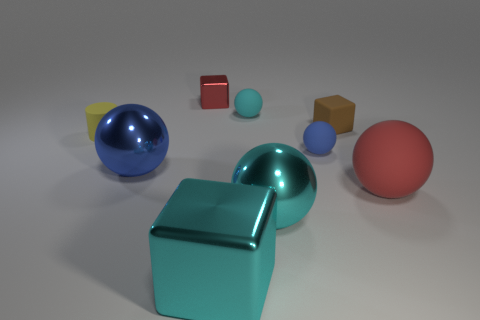What is the overall mood or atmosphere conveyed by the image? The image conveys a clean and serene atmosphere, with a minimalist arrangement of objects on a neutral background. The soft lighting and gentle reflections contribute to a calm and balanced visual experience. 